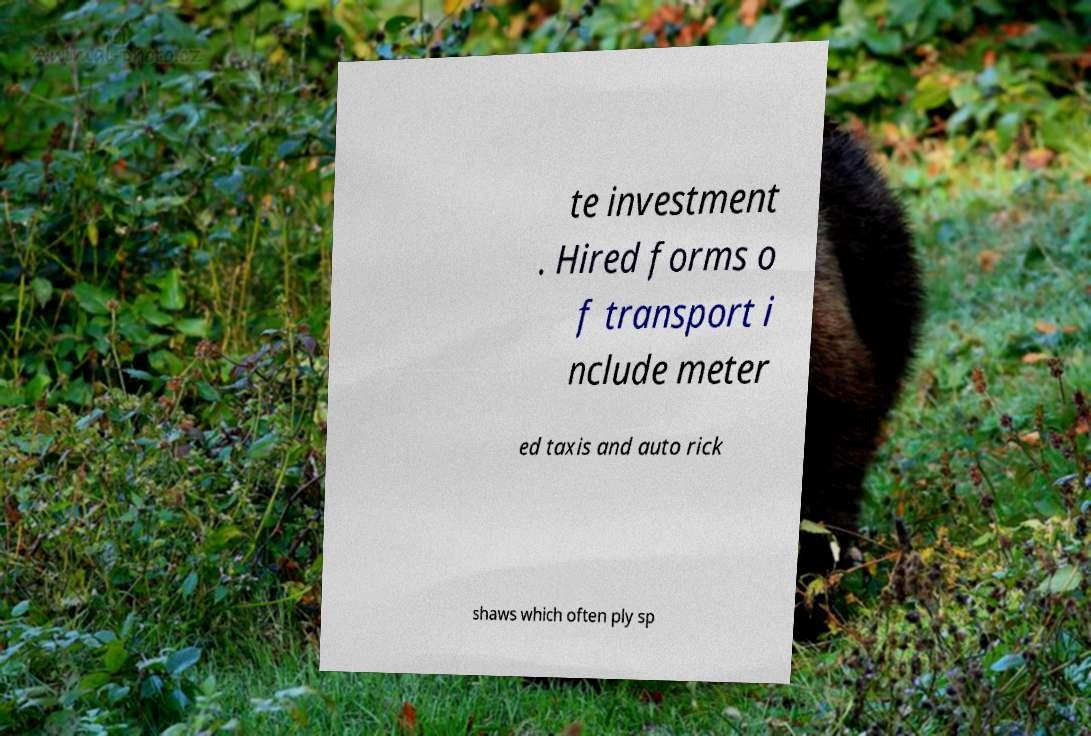What messages or text are displayed in this image? I need them in a readable, typed format. te investment . Hired forms o f transport i nclude meter ed taxis and auto rick shaws which often ply sp 